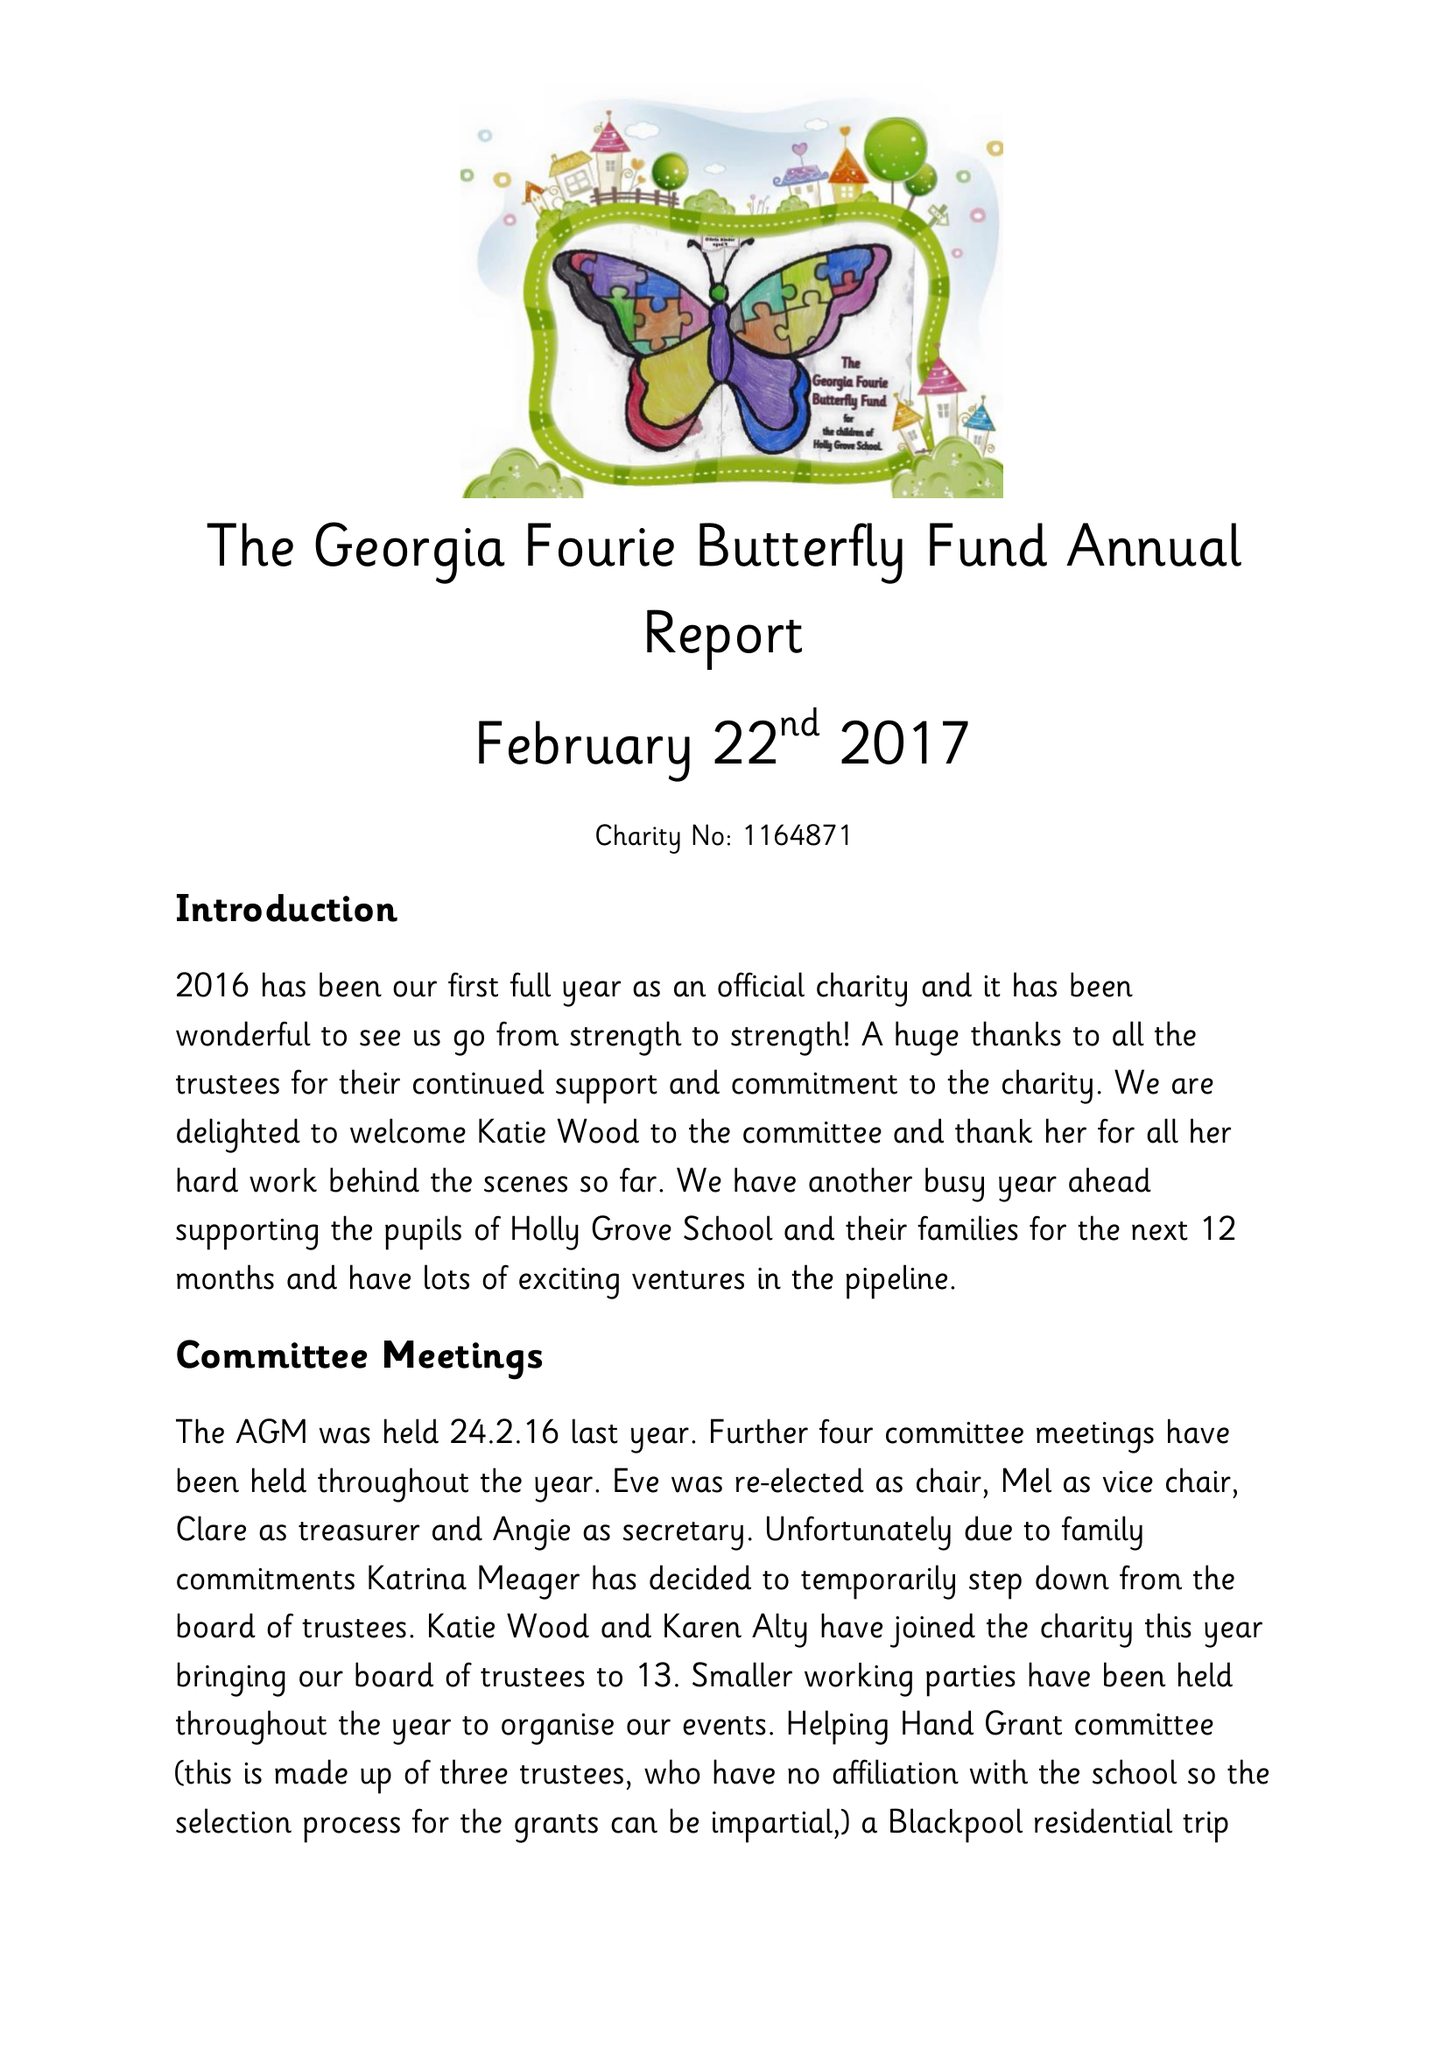What is the value for the spending_annually_in_british_pounds?
Answer the question using a single word or phrase. 31421.00 